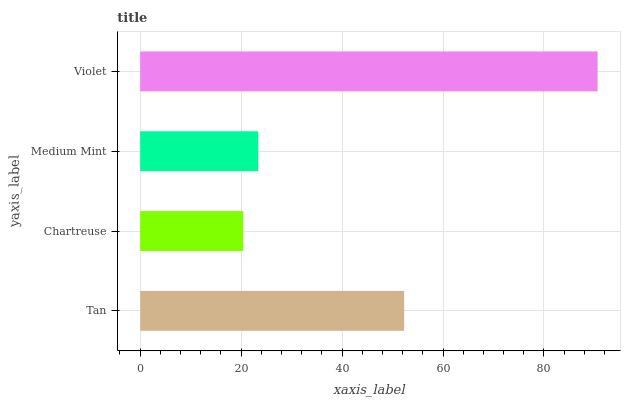Is Chartreuse the minimum?
Answer yes or no. Yes. Is Violet the maximum?
Answer yes or no. Yes. Is Medium Mint the minimum?
Answer yes or no. No. Is Medium Mint the maximum?
Answer yes or no. No. Is Medium Mint greater than Chartreuse?
Answer yes or no. Yes. Is Chartreuse less than Medium Mint?
Answer yes or no. Yes. Is Chartreuse greater than Medium Mint?
Answer yes or no. No. Is Medium Mint less than Chartreuse?
Answer yes or no. No. Is Tan the high median?
Answer yes or no. Yes. Is Medium Mint the low median?
Answer yes or no. Yes. Is Medium Mint the high median?
Answer yes or no. No. Is Tan the low median?
Answer yes or no. No. 